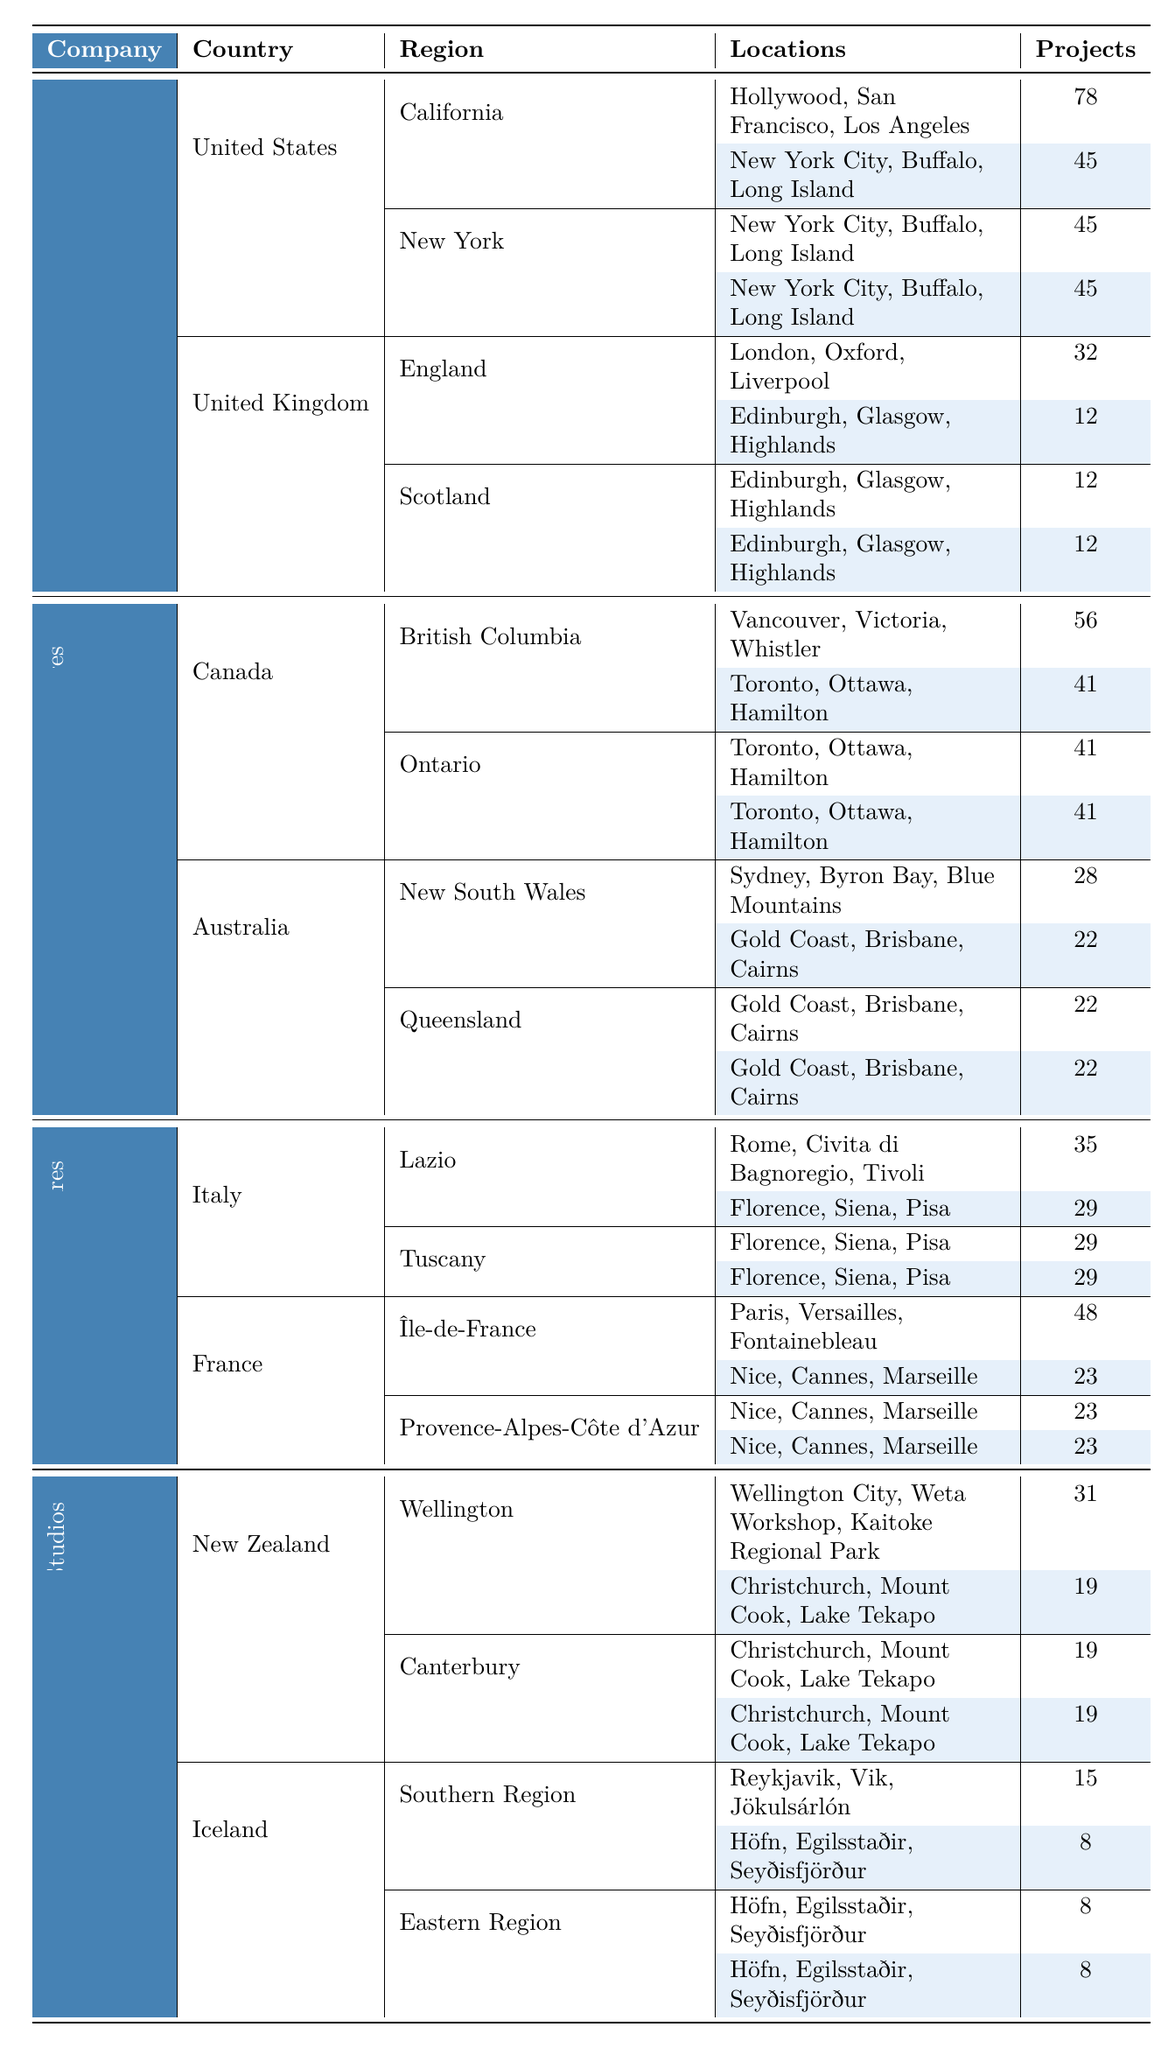What is the total number of projects filmed by Warner Bros. in the United States? Warner Bros. has projects in two regions in the United States. California has 78 projects, and New York has 45 projects. Adding these gives us 78 + 45 = 123 projects in total.
Answer: 123 Which country has the highest number of projects filmed by Universal Pictures? Universal Pictures films in Canada and Australia. Canada has 56 projects in British Columbia and 41 in Ontario, totaling 97 projects. Australia has 28 projects in New South Wales and 22 in Queensland, totaling 50 projects. Since 97 is greater than 50, Canada is the country with the highest projects.
Answer: Canada How many locations does Paramount Pictures have in Tuscany? Paramount Pictures listed three locations in Tuscany: Florence, Siena, and Pisa. Therefore, the number of locations in Tuscany is 3.
Answer: 3 What is the average number of projects across all regions in the United Kingdom for Warner Bros.? In the United Kingdom, Warner Bros. has 32 projects in England and 12 in Scotland. The average is calculated by summing the projects (32 + 12 = 44) and dividing by the number of regions (2). Hence, the average is 44 / 2 = 22.
Answer: 22 How many total projects were filmed by 20th Century Studios in New Zealand? 20th Century Studios filmed in two regions in New Zealand: Wellington has 31 projects and Canterbury has 19 projects. The total is 31 + 19 = 50 projects in New Zealand.
Answer: 50 Is there a region in Canada where Universal Pictures filmed fewer projects than in Queensland? Universal has 56 projects in British Columbia and 41 in Ontario, while Queensland has 22 projects. The lowest is in Queensland, which has fewer projects than both British Columbia and Ontario; hence the statement is true.
Answer: Yes Which production company has filmed in both Italy and France, and what is the combined total of projects in those countries? Paramount Pictures has filmed in Italy (64 projects: 35 in Lazio and 29 in Tuscany) and in France (71 projects: 48 in Île-de-France and 23 in Provence-Alpes-Côte d'Azur). The combined total is 64 + 71 = 135 projects.
Answer: 135 How many locations were used by Universal Pictures in British Columbia? The locations listed by Universal Pictures in British Columbia are Vancouver, Victoria, and Whistler. Thus, there are 3 locations in that region.
Answer: 3 Which production company used fewer locations in France than projects filmed? Paramount Pictures filmed a total of 71 projects in France (48 in Île-de-France and 23 in Provence-Alpes-Côte d'Azur), while it has listed 6 total locations (3 in each region). Since 6 is fewer than 71, the answer is Paramount Pictures.
Answer: Paramount Pictures What is the difference in the number of projects between Universal Pictures in Canada and Warner Bros. in the United States? Universal Pictures has 97 projects in Canada (56 in British Columbia and 41 in Ontario), while Warner Bros. has 123 projects in the United States. The difference is 123 - 97 = 26 projects.
Answer: 26 